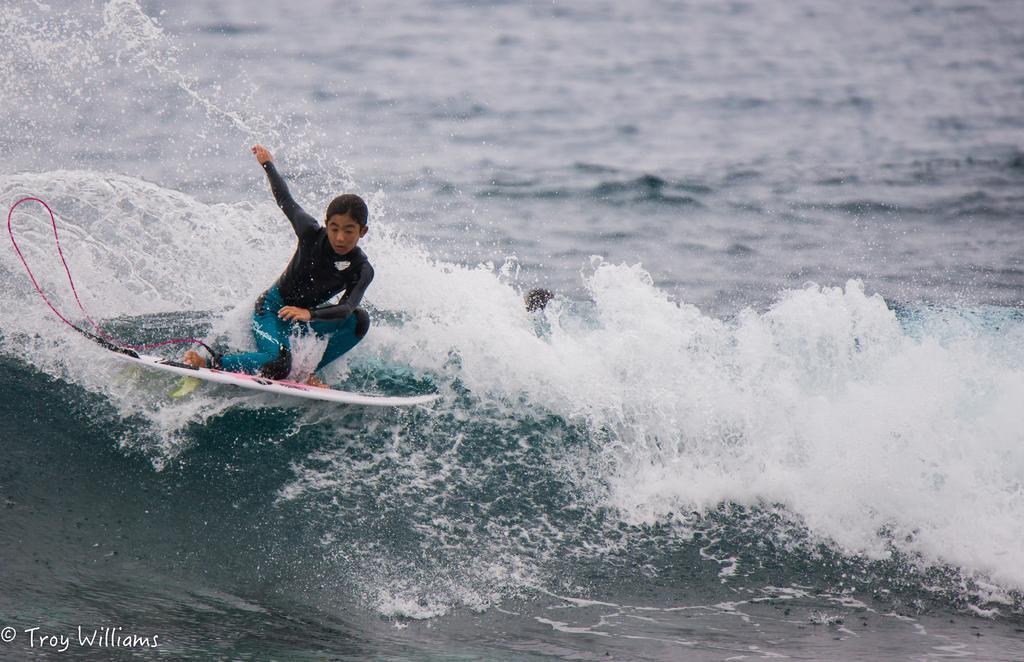In one or two sentences, can you explain what this image depicts? In this image, on the left side, we can see a girl riding on the surfboard. In the background, we can see a water in an ocean. 